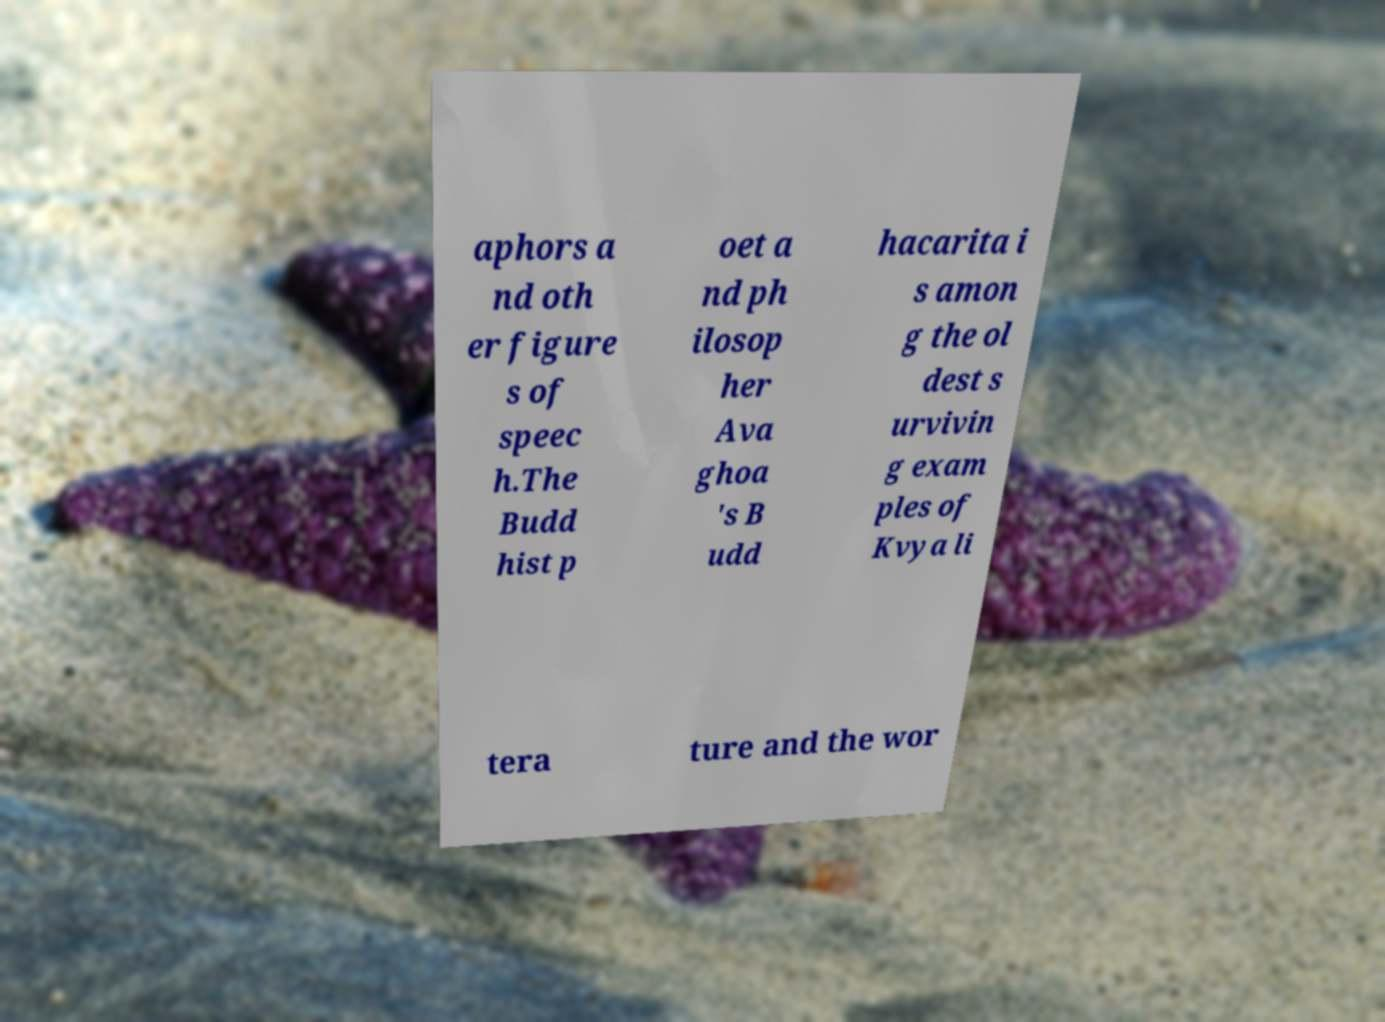Can you read and provide the text displayed in the image?This photo seems to have some interesting text. Can you extract and type it out for me? aphors a nd oth er figure s of speec h.The Budd hist p oet a nd ph ilosop her Ava ghoa 's B udd hacarita i s amon g the ol dest s urvivin g exam ples of Kvya li tera ture and the wor 